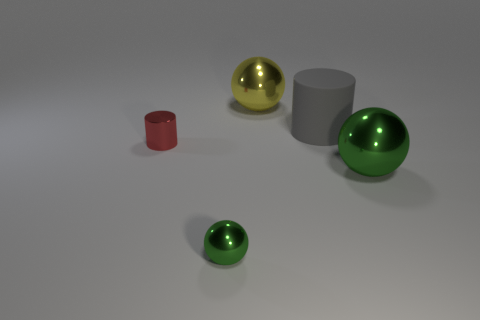The other ball that is the same color as the small metal ball is what size?
Offer a very short reply. Large. What is the shape of the shiny thing that is the same color as the small metal sphere?
Make the answer very short. Sphere. What number of other things are the same material as the red cylinder?
Your answer should be compact. 3. There is a big metallic ball that is behind the red metallic cylinder; what is its color?
Ensure brevity in your answer.  Yellow. What is the material of the green object that is left of the green metal thing that is right of the large cylinder that is behind the small metal sphere?
Offer a very short reply. Metal. Is there a gray object that has the same shape as the small red thing?
Your response must be concise. Yes. What is the shape of the other green thing that is the same size as the matte object?
Offer a terse response. Sphere. How many shiny things are in front of the small red cylinder and right of the tiny green metal thing?
Provide a succinct answer. 1. Is the number of tiny objects to the right of the large yellow metallic thing less than the number of tiny objects?
Make the answer very short. Yes. Are there any other things of the same size as the rubber thing?
Provide a short and direct response. Yes. 